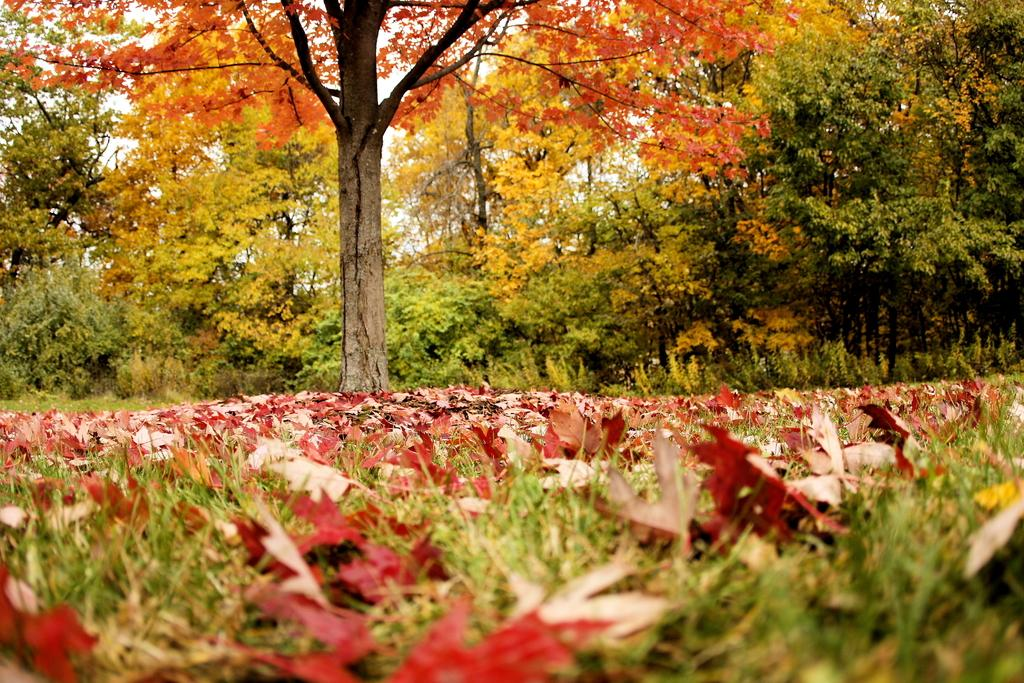What type of vegetation can be seen in the image? There are plants and trees in the image. What is on the ground in the image? There are leaves on the ground in the image. What type of ground cover is present in the image? There is grass in the image. What is visible in the background of the image? The sky is visible in the image. What type of art can be seen on the leaves in the image? There is no art present on the leaves in the image; they are simply fallen leaves on the ground. 